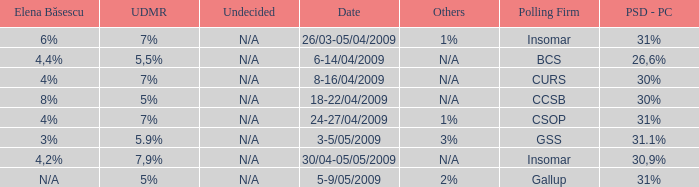What is the psd-pc for 18-22/04/2009? 30%. 